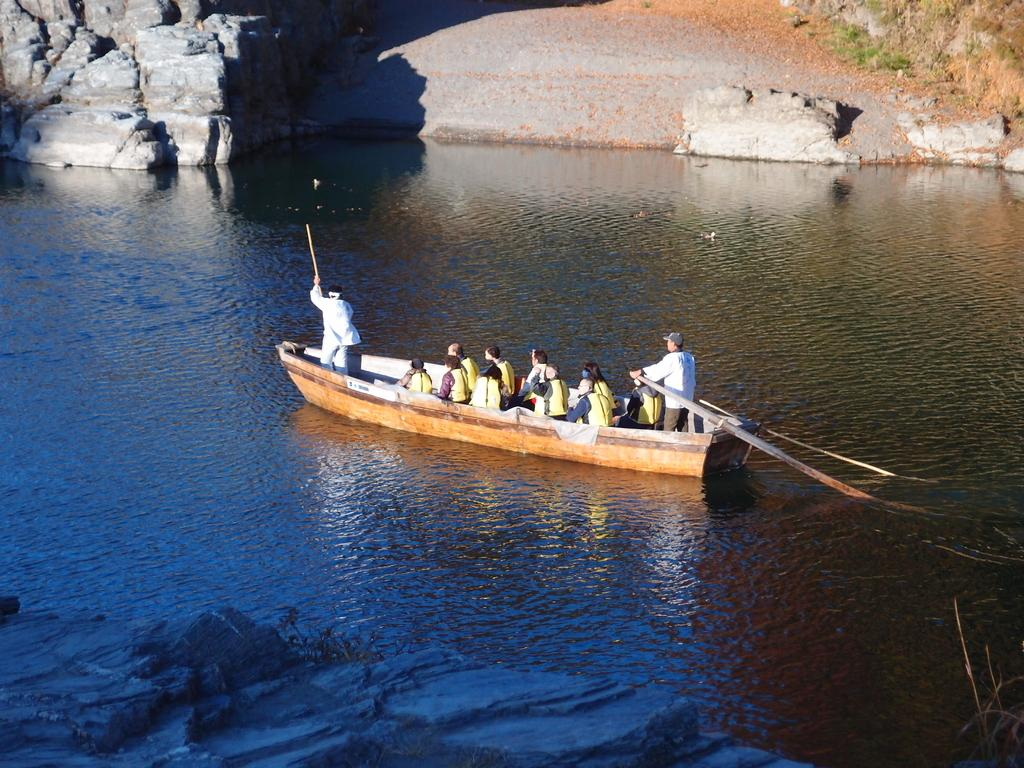How many people are visible in the image? There are people in the image, with two people standing and others sitting on the water. Can you describe the position of the standing people in the image? Two people are standing in the image. What is the unusual aspect of the people sitting in the image? Other people are sitting on the water in the image. What can be seen in the background of the image? There are rocks in the background of the image. What is the answer to the riddle that is being told in the image? There is no riddle being told in the image, so it is not possible to answer that question. 